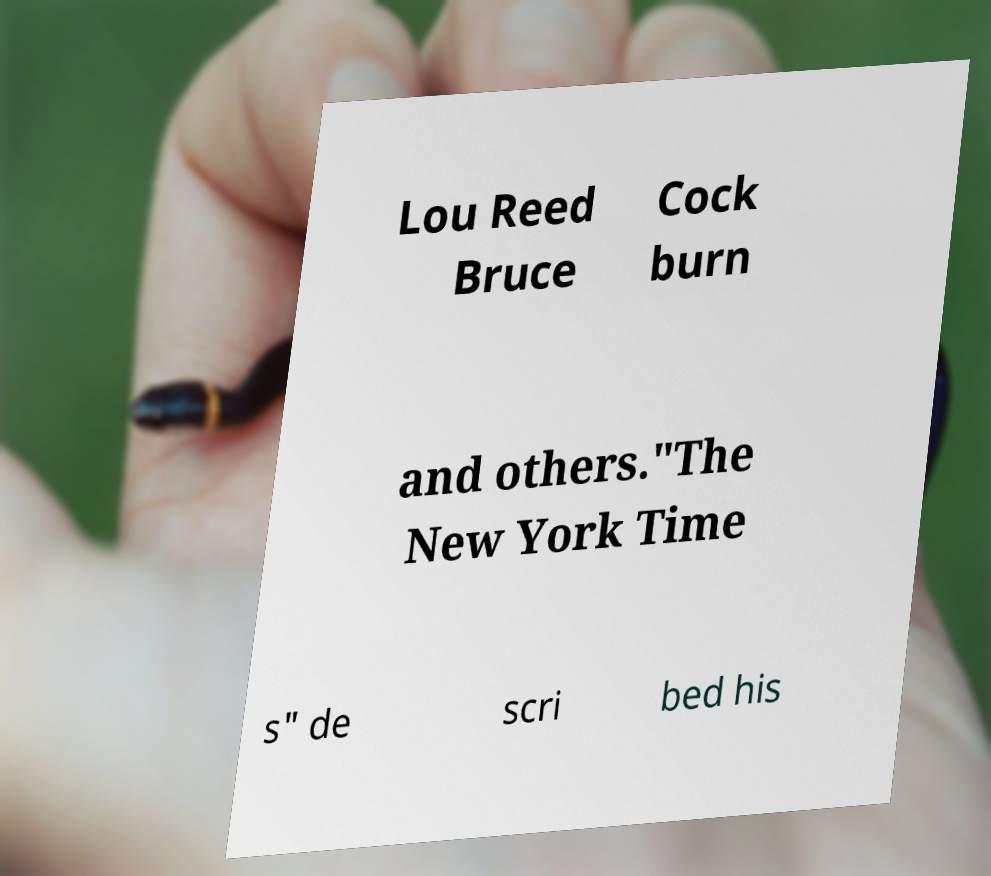Could you assist in decoding the text presented in this image and type it out clearly? Lou Reed Bruce Cock burn and others."The New York Time s" de scri bed his 